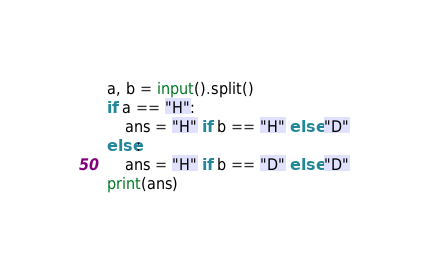<code> <loc_0><loc_0><loc_500><loc_500><_Python_>a, b = input().split()
if a == "H":
    ans = "H" if b == "H" else "D"
else:
    ans = "H" if b == "D" else "D"
print(ans)</code> 